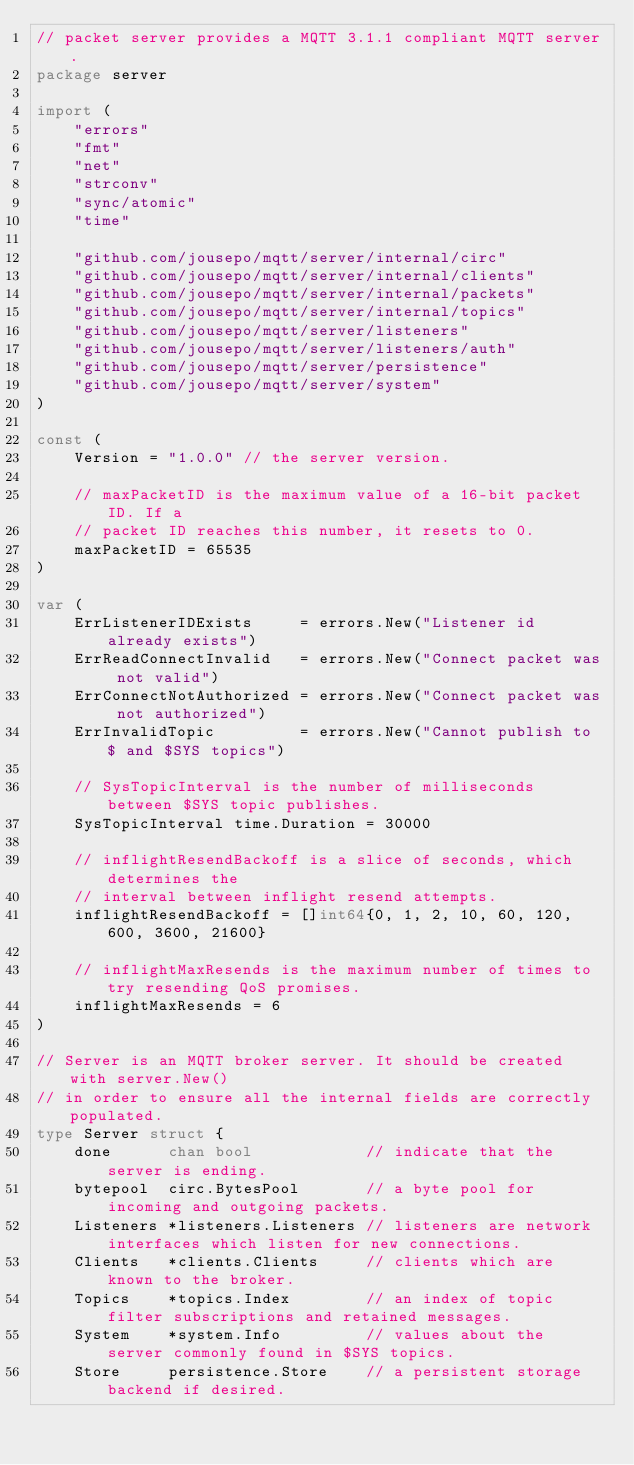Convert code to text. <code><loc_0><loc_0><loc_500><loc_500><_Go_>// packet server provides a MQTT 3.1.1 compliant MQTT server.
package server

import (
	"errors"
	"fmt"
	"net"
	"strconv"
	"sync/atomic"
	"time"

	"github.com/jousepo/mqtt/server/internal/circ"
	"github.com/jousepo/mqtt/server/internal/clients"
	"github.com/jousepo/mqtt/server/internal/packets"
	"github.com/jousepo/mqtt/server/internal/topics"
	"github.com/jousepo/mqtt/server/listeners"
	"github.com/jousepo/mqtt/server/listeners/auth"
	"github.com/jousepo/mqtt/server/persistence"
	"github.com/jousepo/mqtt/server/system"
)

const (
	Version = "1.0.0" // the server version.

	// maxPacketID is the maximum value of a 16-bit packet ID. If a
	// packet ID reaches this number, it resets to 0.
	maxPacketID = 65535
)

var (
	ErrListenerIDExists     = errors.New("Listener id already exists")
	ErrReadConnectInvalid   = errors.New("Connect packet was not valid")
	ErrConnectNotAuthorized = errors.New("Connect packet was not authorized")
	ErrInvalidTopic         = errors.New("Cannot publish to $ and $SYS topics")

	// SysTopicInterval is the number of milliseconds between $SYS topic publishes.
	SysTopicInterval time.Duration = 30000

	// inflightResendBackoff is a slice of seconds, which determines the
	// interval between inflight resend attempts.
	inflightResendBackoff = []int64{0, 1, 2, 10, 60, 120, 600, 3600, 21600}

	// inflightMaxResends is the maximum number of times to try resending QoS promises.
	inflightMaxResends = 6
)

// Server is an MQTT broker server. It should be created with server.New()
// in order to ensure all the internal fields are correctly populated.
type Server struct {
	done      chan bool            // indicate that the server is ending.
	bytepool  circ.BytesPool       // a byte pool for incoming and outgoing packets.
	Listeners *listeners.Listeners // listeners are network interfaces which listen for new connections.
	Clients   *clients.Clients     // clients which are known to the broker.
	Topics    *topics.Index        // an index of topic filter subscriptions and retained messages.
	System    *system.Info         // values about the server commonly found in $SYS topics.
	Store     persistence.Store    // a persistent storage backend if desired.</code> 